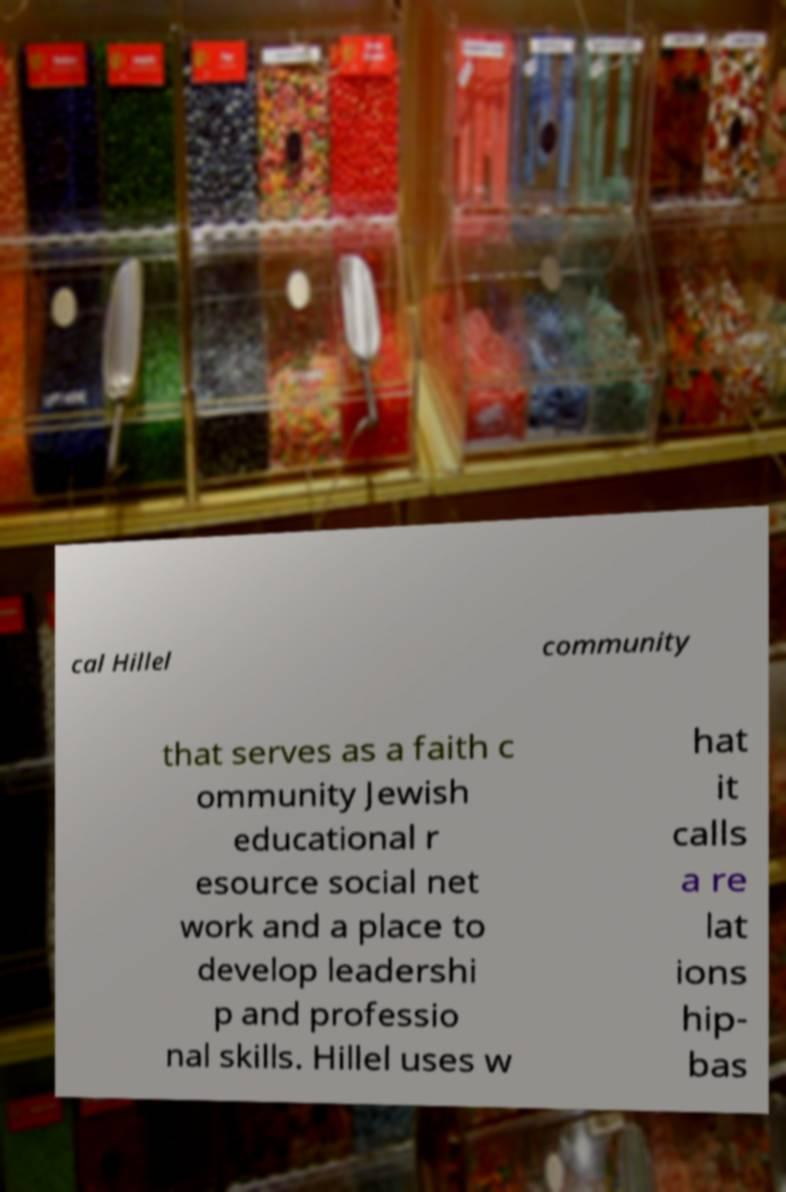Please identify and transcribe the text found in this image. cal Hillel community that serves as a faith c ommunity Jewish educational r esource social net work and a place to develop leadershi p and professio nal skills. Hillel uses w hat it calls a re lat ions hip- bas 